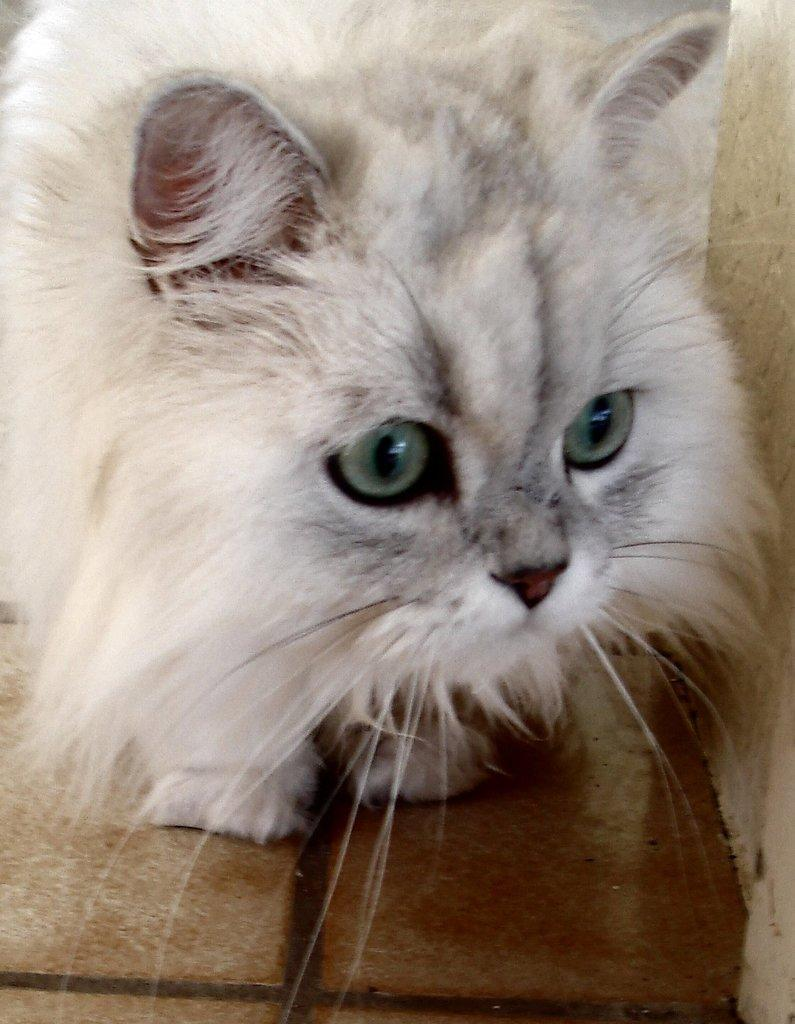What type of animal is in the image? There is a cat in the image. Can you describe the color of the cat? The cat is white in color. How many chickens are present in the image? There are no chickens present in the image; it features a white cat. What type of string is the visitor using to interact with the cat in the image? There is no visitor or string present in the image; it only features a white cat. 